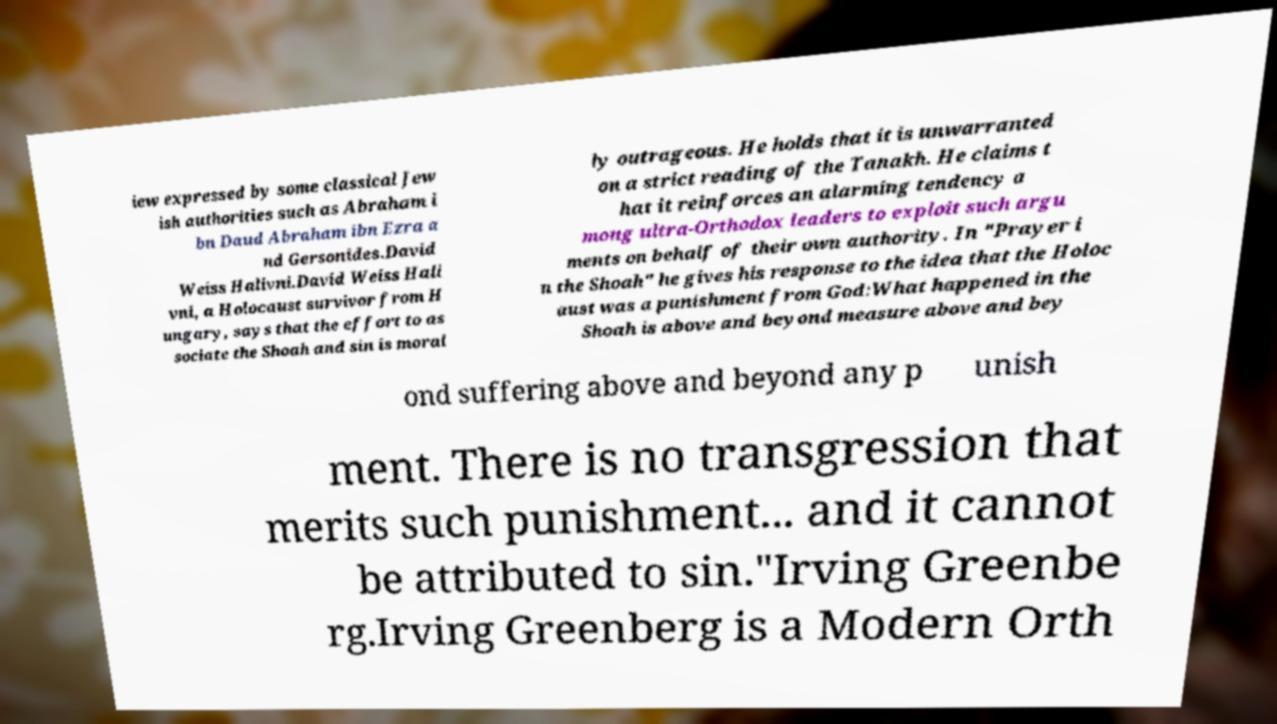Can you read and provide the text displayed in the image?This photo seems to have some interesting text. Can you extract and type it out for me? iew expressed by some classical Jew ish authorities such as Abraham i bn Daud Abraham ibn Ezra a nd Gersonides.David Weiss Halivni.David Weiss Hali vni, a Holocaust survivor from H ungary, says that the effort to as sociate the Shoah and sin is moral ly outrageous. He holds that it is unwarranted on a strict reading of the Tanakh. He claims t hat it reinforces an alarming tendency a mong ultra-Orthodox leaders to exploit such argu ments on behalf of their own authority. In "Prayer i n the Shoah" he gives his response to the idea that the Holoc aust was a punishment from God:What happened in the Shoah is above and beyond measure above and bey ond suffering above and beyond any p unish ment. There is no transgression that merits such punishment... and it cannot be attributed to sin."Irving Greenbe rg.Irving Greenberg is a Modern Orth 